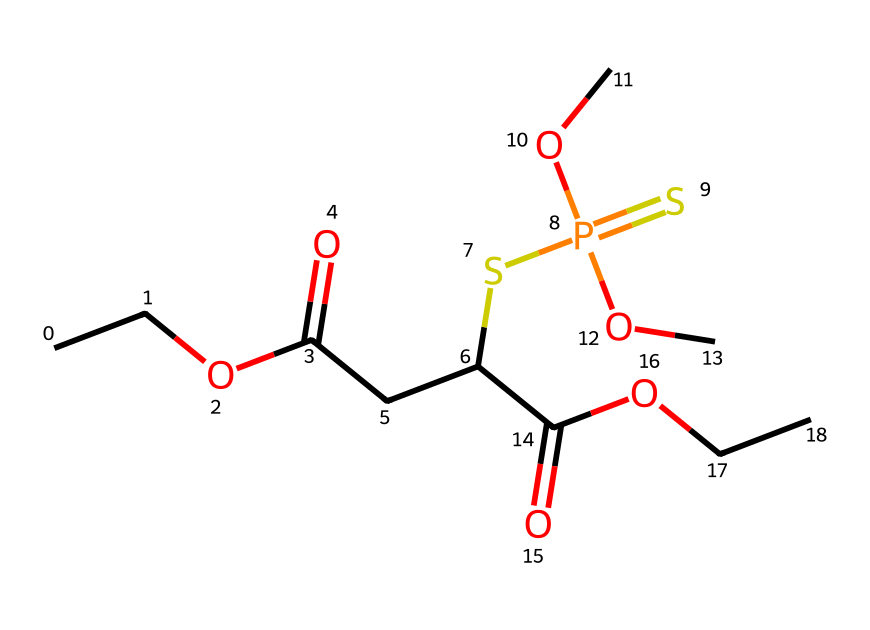How many carbon atoms are in this molecule? By examining the SMILES representation, the molecule contains four distinct carbon atoms at various positions along the chain.
Answer: four What functional groups are present in this chemical structure? The SMILES reveals the presence of an ester (due to COC and C(=O)O) and a thiophosphate group (SP(=S)(OC)OC), indicating multiple functional groups.
Answer: ester and thiophosphate What is the total number of oxygen atoms in this structure? Counting the oxygen atoms in the SMILES, we see three oxygen atoms: one in the ester group, one in the carboxylic acid, and two in the thiophosphate group.
Answer: four What type of pesticide is malathion classified as? Malathion, represented in the given structure, belongs to the class of organophosphate pesticides, known for their action on insect nervous systems.
Answer: organophosphate Which element is responsible for the 'sulfur' classification in this compound? The presence of the 'S' in the SMILES indicates sulfur atoms are present in the structure, particularly in the thiophosphate component.
Answer: sulfur What is the role of sulfur in malathion's effectiveness as a pesticide? Sulfur contributes to the inhibition of the enzyme acetylcholinesterase, which is vital for terminating nerve signal transmission in pests, thus enhancing its effectiveness.
Answer: inhibit acetylcholinesterase 